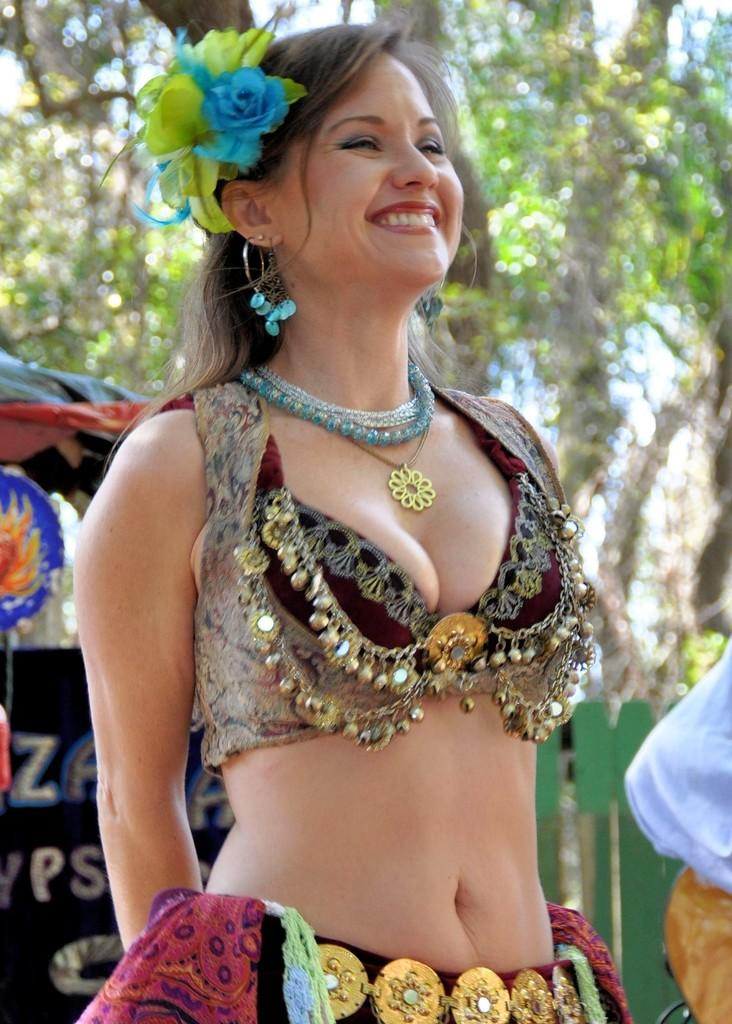Who is the main subject in the image? There is a woman in the front of the image. What can be seen in the background of the image? There are trees in the background of the image. What type of bomb is being diffused by the woman in the image? There is no bomb present in the image; it features a woman and trees in the background. How many fish can be seen swimming in the water near the woman in the image? There is no water or fish present in the image; it features a woman and trees in the background. 